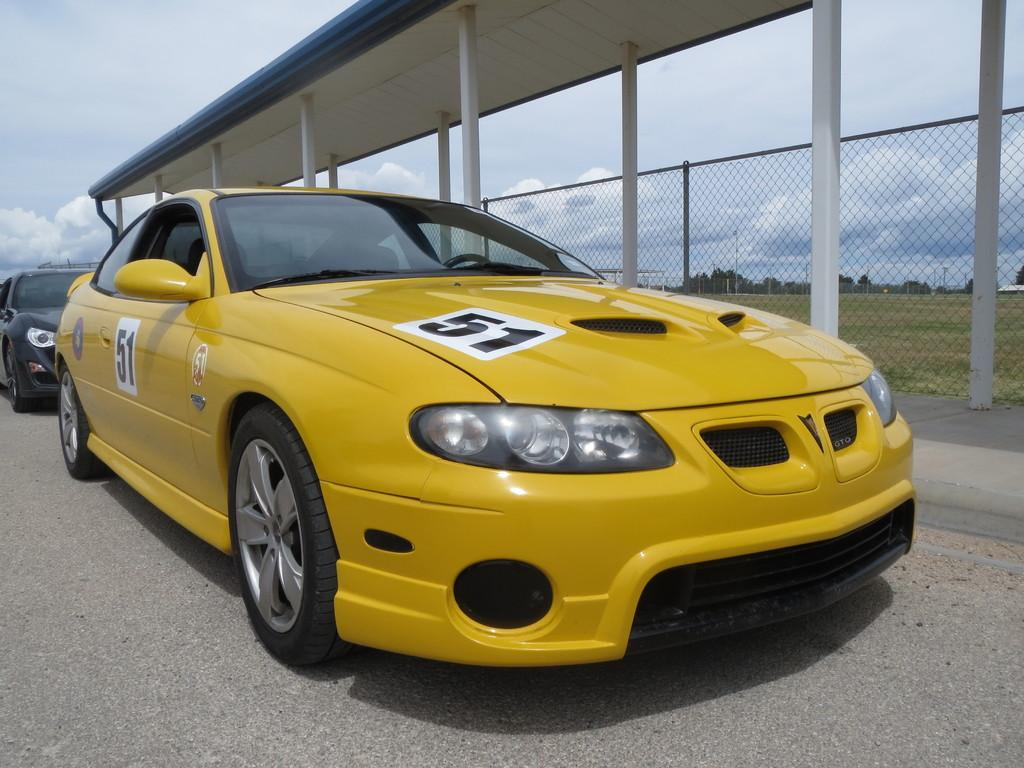How many vehicles can be seen on the road in the image? There are two vehicles on the road in the image. What type of structure is present in the image? There is a shed in the image. What are the vertical structures visible in the image? There are poles visible in the image. What type of vegetation is present in the image? There are trees in the image. What part of the ground can be seen in the image? The ground is visible in the image. What type of barrier is present in the image? There is a fence in the image. What can be seen in the background of the image? The sky with clouds is visible in the background. What type of pen is being used to write on the fence in the image? There is no pen or writing present on the fence in the image. What type of operation is being performed on the vehicles in the image? There is no operation being performed on the vehicles in the image; they are simply parked on the road. 